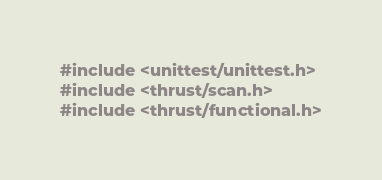<code> <loc_0><loc_0><loc_500><loc_500><_Cuda_>#include <unittest/unittest.h>
#include <thrust/scan.h>
#include <thrust/functional.h></code> 